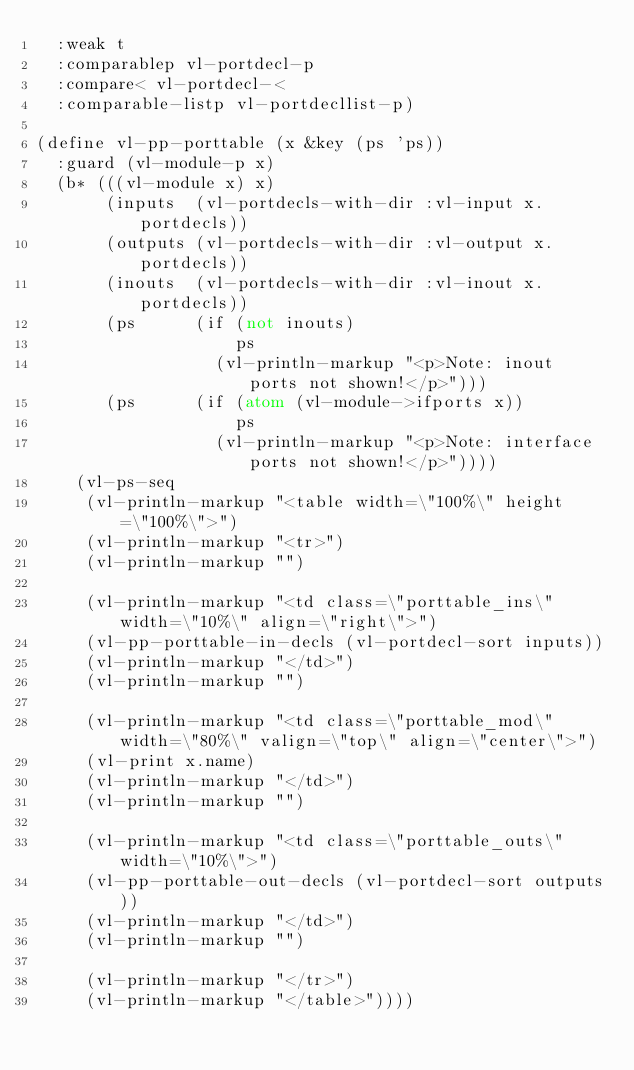<code> <loc_0><loc_0><loc_500><loc_500><_Lisp_>  :weak t
  :comparablep vl-portdecl-p
  :compare< vl-portdecl-<
  :comparable-listp vl-portdecllist-p)

(define vl-pp-porttable (x &key (ps 'ps))
  :guard (vl-module-p x)
  (b* (((vl-module x) x)
       (inputs  (vl-portdecls-with-dir :vl-input x.portdecls))
       (outputs (vl-portdecls-with-dir :vl-output x.portdecls))
       (inouts  (vl-portdecls-with-dir :vl-inout x.portdecls))
       (ps      (if (not inouts)
                    ps
                  (vl-println-markup "<p>Note: inout ports not shown!</p>")))
       (ps      (if (atom (vl-module->ifports x))
                    ps
                  (vl-println-markup "<p>Note: interface ports not shown!</p>"))))
    (vl-ps-seq
     (vl-println-markup "<table width=\"100%\" height=\"100%\">")
     (vl-println-markup "<tr>")
     (vl-println-markup "")

     (vl-println-markup "<td class=\"porttable_ins\" width=\"10%\" align=\"right\">")
     (vl-pp-porttable-in-decls (vl-portdecl-sort inputs))
     (vl-println-markup "</td>")
     (vl-println-markup "")

     (vl-println-markup "<td class=\"porttable_mod\" width=\"80%\" valign=\"top\" align=\"center\">")
     (vl-print x.name)
     (vl-println-markup "</td>")
     (vl-println-markup "")

     (vl-println-markup "<td class=\"porttable_outs\" width=\"10%\">")
     (vl-pp-porttable-out-decls (vl-portdecl-sort outputs))
     (vl-println-markup "</td>")
     (vl-println-markup "")

     (vl-println-markup "</tr>")
     (vl-println-markup "</table>"))))


</code> 